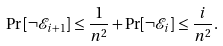<formula> <loc_0><loc_0><loc_500><loc_500>\Pr \left [ \neg \mathcal { E } _ { i + 1 } \right ] \leq \frac { 1 } { n ^ { 2 } } + \Pr [ \neg \mathcal { E } _ { i } ] \leq \frac { i } { n ^ { 2 } } .</formula> 